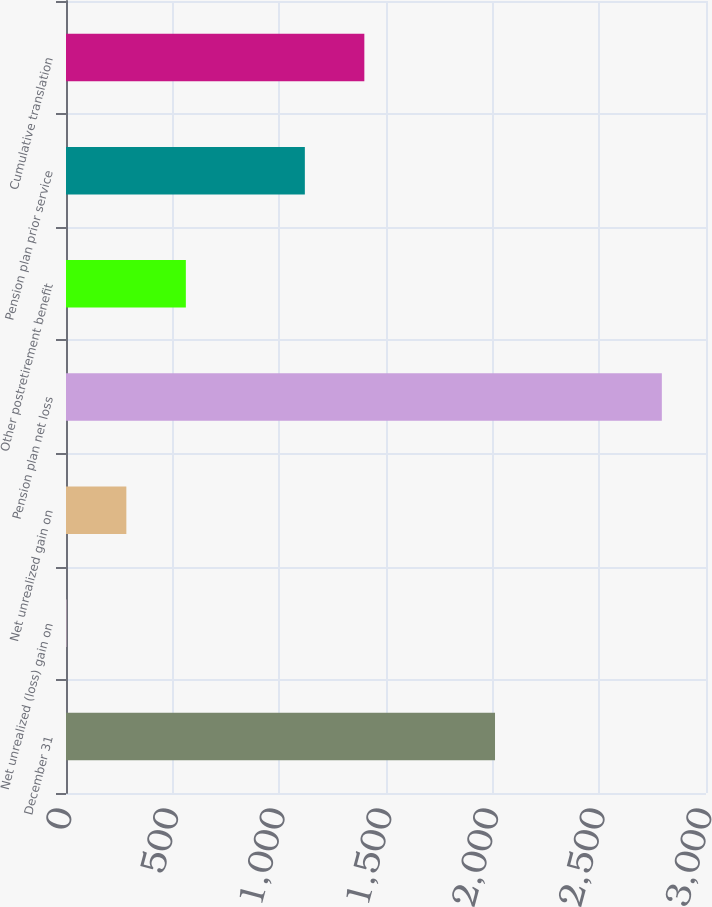Convert chart. <chart><loc_0><loc_0><loc_500><loc_500><bar_chart><fcel>December 31<fcel>Net unrealized (loss) gain on<fcel>Net unrealized gain on<fcel>Pension plan net loss<fcel>Other postretirement benefit<fcel>Pension plan prior service<fcel>Cumulative translation<nl><fcel>2011<fcel>4<fcel>282.9<fcel>2793<fcel>561.8<fcel>1119.6<fcel>1398.5<nl></chart> 